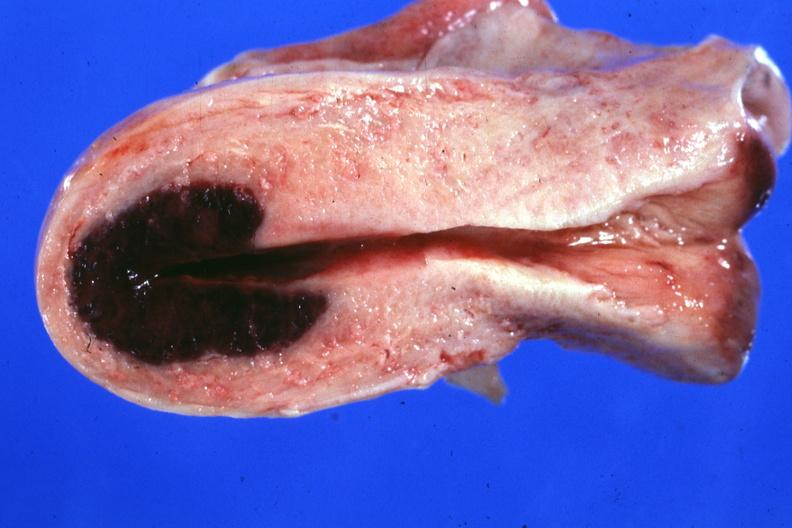s lesion in dome of uterus said to have adenosis adenomyosis hemorrhage probably due to shock?
Answer the question using a single word or phrase. Yes 